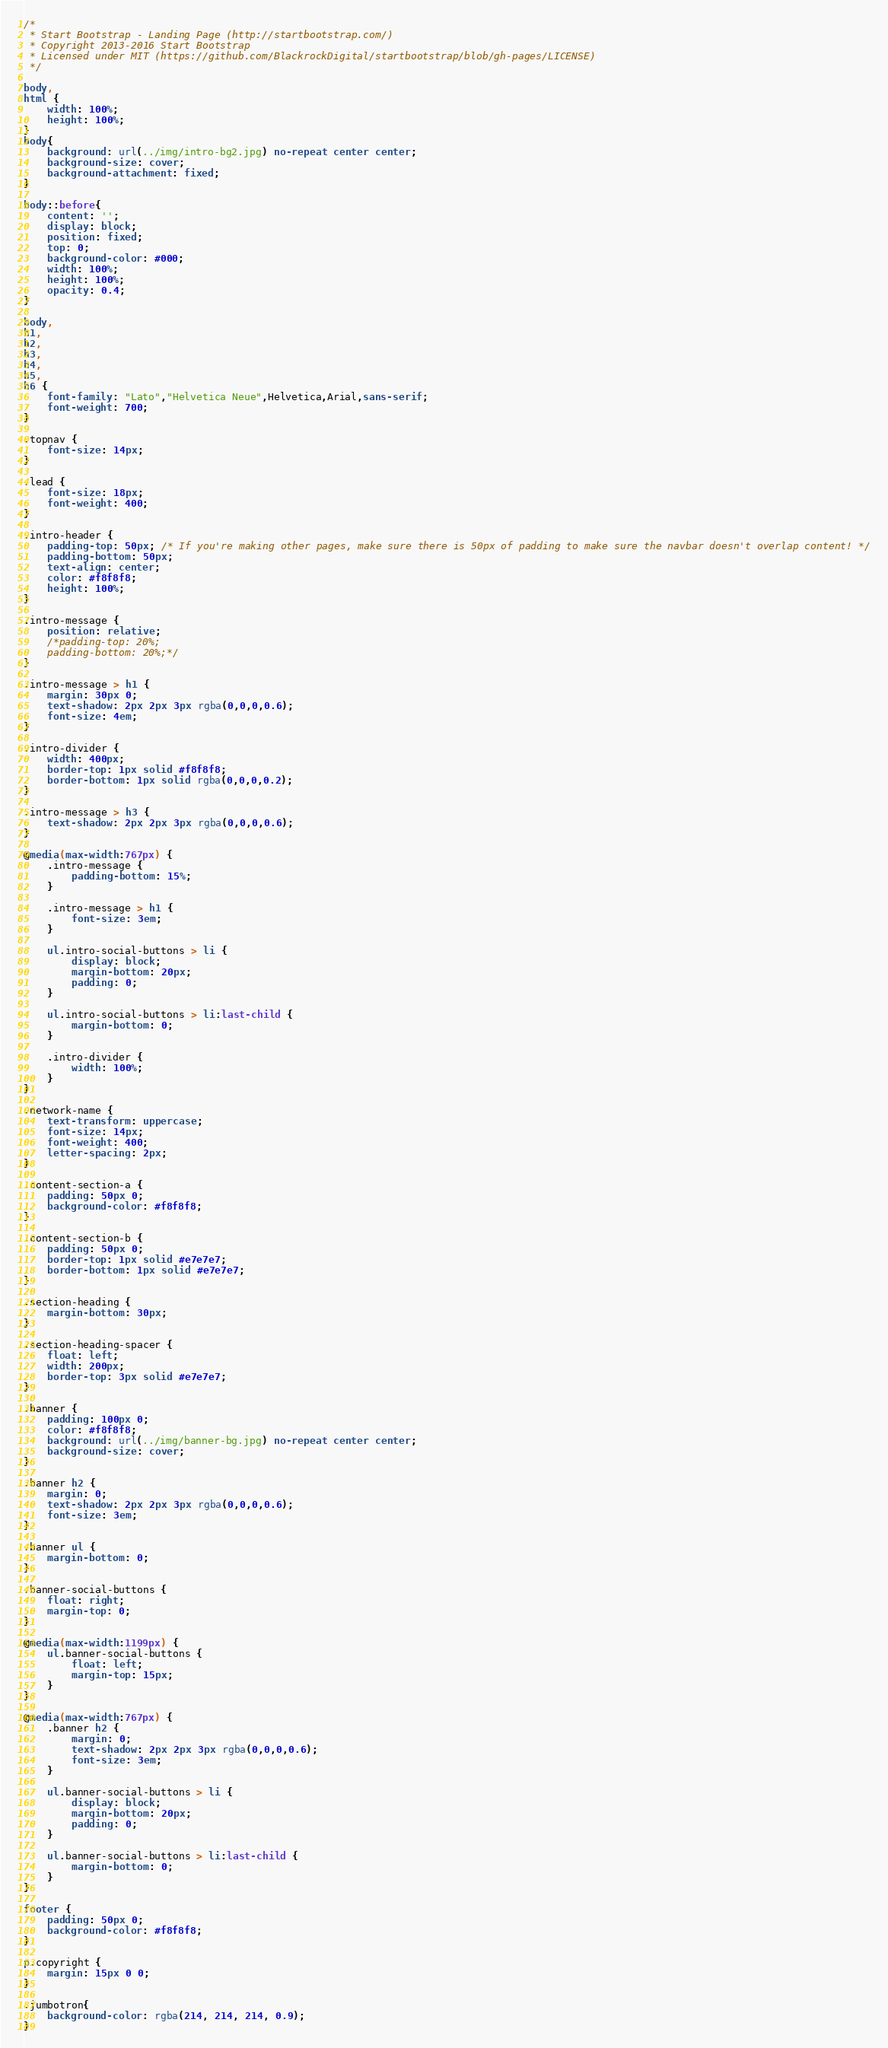Convert code to text. <code><loc_0><loc_0><loc_500><loc_500><_CSS_>/*
 * Start Bootstrap - Landing Page (http://startbootstrap.com/)
 * Copyright 2013-2016 Start Bootstrap
 * Licensed under MIT (https://github.com/BlackrockDigital/startbootstrap/blob/gh-pages/LICENSE)
 */

body,
html {
    width: 100%;
    height: 100%;
}
body{
    background: url(../img/intro-bg2.jpg) no-repeat center center; 
    background-size: cover;
    background-attachment: fixed;
}

body::before{
    content: '';
    display: block;
    position: fixed;
    top: 0;
    background-color: #000; 
    width: 100%;
    height: 100%;
    opacity: 0.4;
}

body,
h1,
h2,
h3,
h4,
h5,
h6 {
    font-family: "Lato","Helvetica Neue",Helvetica,Arial,sans-serif;
    font-weight: 700;
}

.topnav {
    font-size: 14px; 
}

.lead {
    font-size: 18px;
    font-weight: 400;
}

.intro-header {
    padding-top: 50px; /* If you're making other pages, make sure there is 50px of padding to make sure the navbar doesn't overlap content! */
    padding-bottom: 50px;
    text-align: center;
    color: #f8f8f8;
    height: 100%; 
}

.intro-message {
    position: relative;
    /*padding-top: 20%;
    padding-bottom: 20%;*/
}

.intro-message > h1 {
    margin: 30px 0;
    text-shadow: 2px 2px 3px rgba(0,0,0,0.6);
    font-size: 4em;
}

.intro-divider {
    width: 400px;
    border-top: 1px solid #f8f8f8;
    border-bottom: 1px solid rgba(0,0,0,0.2);
}

.intro-message > h3 {
    text-shadow: 2px 2px 3px rgba(0,0,0,0.6);
}

@media(max-width:767px) {
    .intro-message {
        padding-bottom: 15%;
    }

    .intro-message > h1 {
        font-size: 3em;
    }

    ul.intro-social-buttons > li {
        display: block;
        margin-bottom: 20px;
        padding: 0;
    }

    ul.intro-social-buttons > li:last-child {
        margin-bottom: 0;
    }

    .intro-divider {
        width: 100%;
    }
}

.network-name {
    text-transform: uppercase;
    font-size: 14px;
    font-weight: 400;
    letter-spacing: 2px;
}

.content-section-a {
    padding: 50px 0;
    background-color: #f8f8f8;
}

.content-section-b {
    padding: 50px 0;
    border-top: 1px solid #e7e7e7;
    border-bottom: 1px solid #e7e7e7;
}

.section-heading {
    margin-bottom: 30px;
}

.section-heading-spacer {
    float: left;
    width: 200px;
    border-top: 3px solid #e7e7e7;
}

.banner {
    padding: 100px 0;
    color: #f8f8f8;
    background: url(../img/banner-bg.jpg) no-repeat center center;
    background-size: cover;
}

.banner h2 {
    margin: 0;
    text-shadow: 2px 2px 3px rgba(0,0,0,0.6);
    font-size: 3em;
}

.banner ul {
    margin-bottom: 0;
}

.banner-social-buttons {
    float: right;
    margin-top: 0;
}

@media(max-width:1199px) {
    ul.banner-social-buttons {
        float: left;
        margin-top: 15px;
    }
}

@media(max-width:767px) {
    .banner h2 {
        margin: 0;
        text-shadow: 2px 2px 3px rgba(0,0,0,0.6);
        font-size: 3em;
    }

    ul.banner-social-buttons > li {
        display: block;
        margin-bottom: 20px;
        padding: 0;
    }

    ul.banner-social-buttons > li:last-child {
        margin-bottom: 0;
    }
}

footer {
    padding: 50px 0;
    background-color: #f8f8f8;
}

p.copyright {
    margin: 15px 0 0;
}

.jumbotron{
    background-color: rgba(214, 214, 214, 0.9);
}</code> 